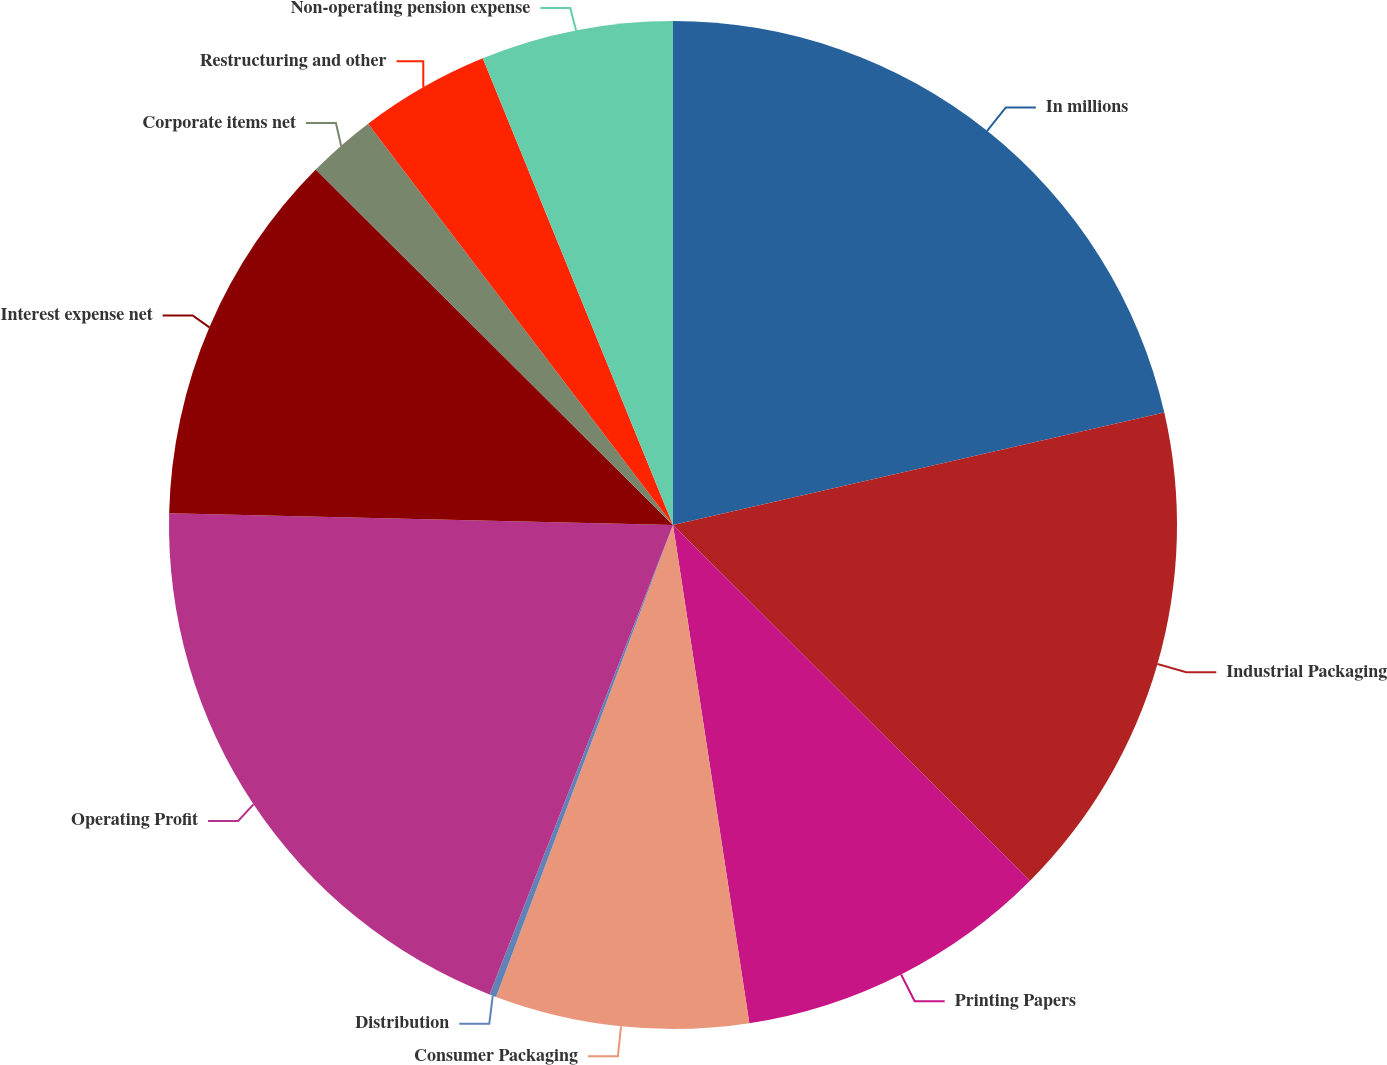Convert chart to OTSL. <chart><loc_0><loc_0><loc_500><loc_500><pie_chart><fcel>In millions<fcel>Industrial Packaging<fcel>Printing Papers<fcel>Consumer Packaging<fcel>Distribution<fcel>Operating Profit<fcel>Interest expense net<fcel>Corporate items net<fcel>Restructuring and other<fcel>Non-operating pension expense<nl><fcel>21.42%<fcel>16.05%<fcel>10.11%<fcel>8.13%<fcel>0.22%<fcel>19.44%<fcel>12.09%<fcel>2.2%<fcel>4.18%<fcel>6.16%<nl></chart> 